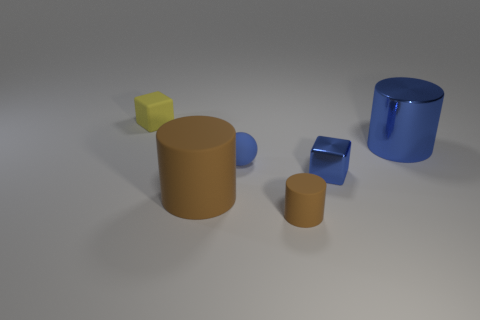Add 2 tiny brown cylinders. How many objects exist? 8 Subtract all balls. How many objects are left? 5 Add 2 brown rubber objects. How many brown rubber objects are left? 4 Add 5 small metal things. How many small metal things exist? 6 Subtract 0 purple cylinders. How many objects are left? 6 Subtract all metallic cubes. Subtract all small matte balls. How many objects are left? 4 